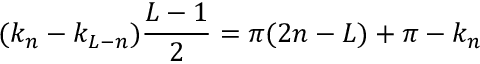Convert formula to latex. <formula><loc_0><loc_0><loc_500><loc_500>( k _ { n } - k _ { L - n } ) \frac { L - 1 } { 2 } = \pi ( 2 n - L ) + \pi - k _ { n }</formula> 